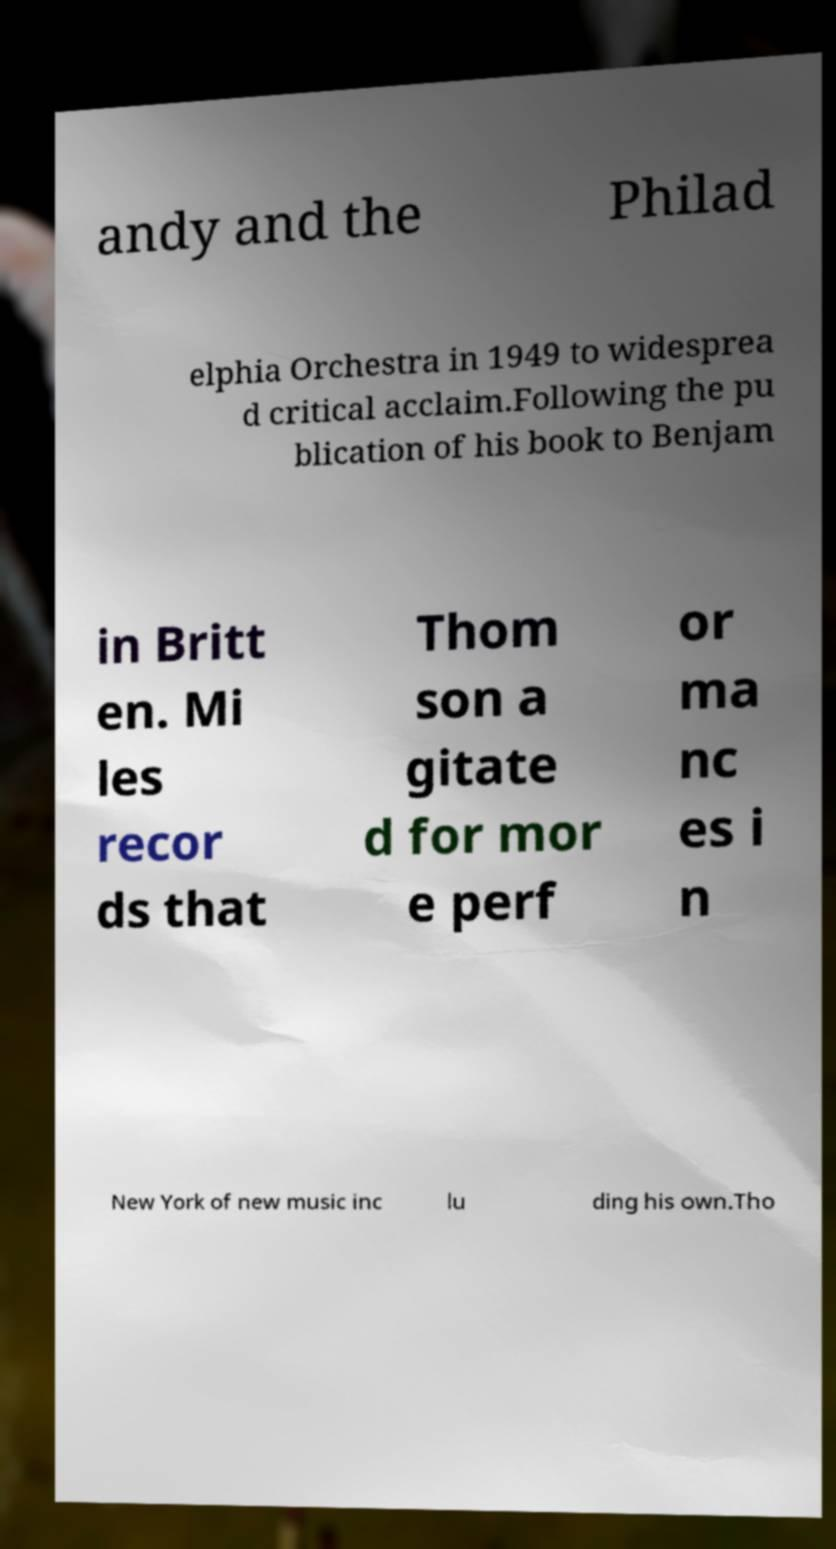For documentation purposes, I need the text within this image transcribed. Could you provide that? andy and the Philad elphia Orchestra in 1949 to widesprea d critical acclaim.Following the pu blication of his book to Benjam in Britt en. Mi les recor ds that Thom son a gitate d for mor e perf or ma nc es i n New York of new music inc lu ding his own.Tho 